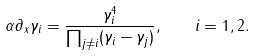<formula> <loc_0><loc_0><loc_500><loc_500>\alpha \partial _ { x } \gamma _ { i } = \frac { \gamma _ { i } ^ { 4 } } { \prod _ { j \neq i } ( \gamma _ { i } - \gamma _ { j } ) } , \quad i = 1 , 2 .</formula> 